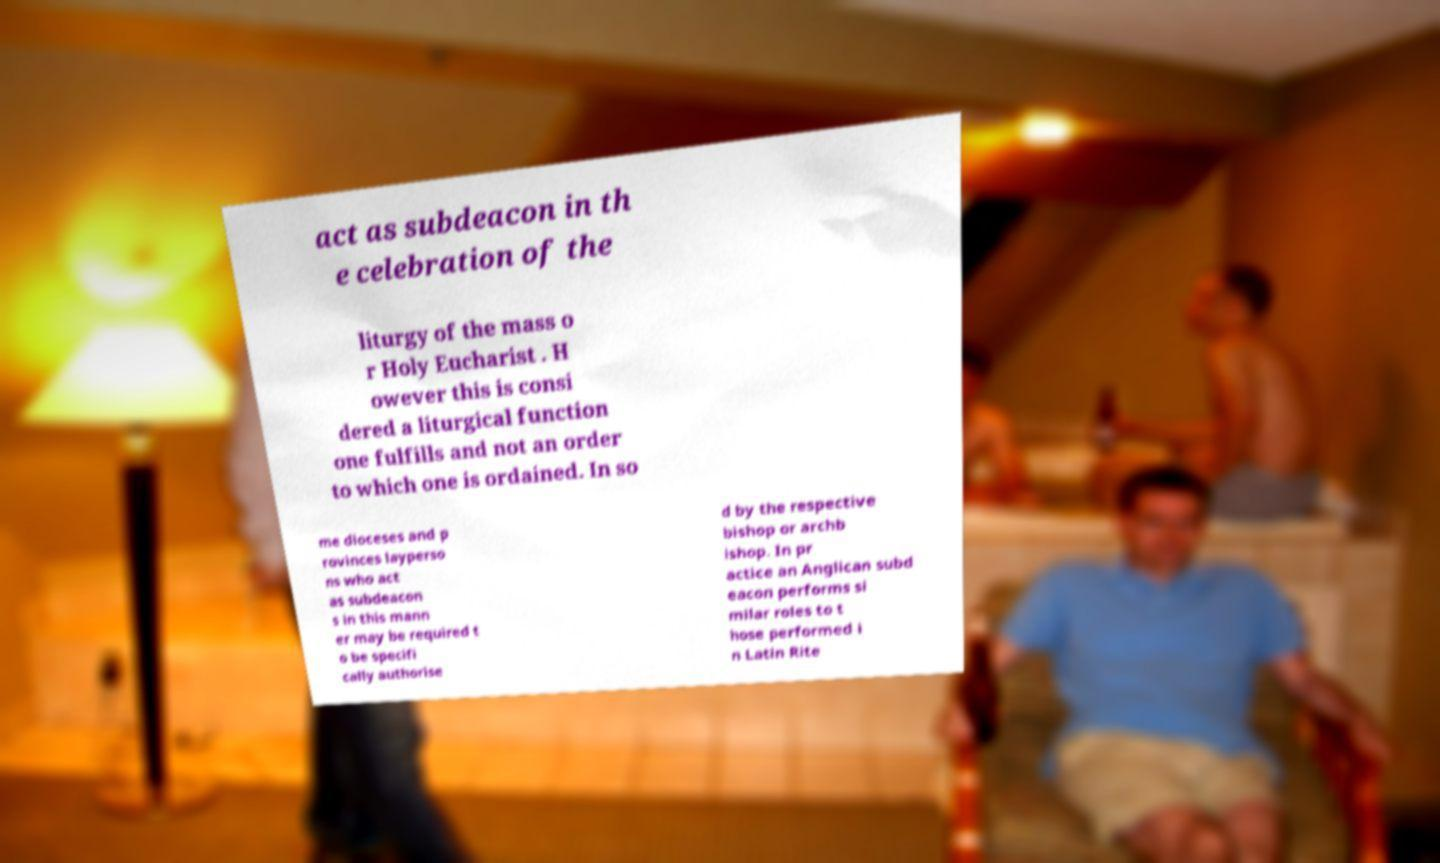For documentation purposes, I need the text within this image transcribed. Could you provide that? act as subdeacon in th e celebration of the liturgy of the mass o r Holy Eucharist . H owever this is consi dered a liturgical function one fulfills and not an order to which one is ordained. In so me dioceses and p rovinces layperso ns who act as subdeacon s in this mann er may be required t o be specifi cally authorise d by the respective bishop or archb ishop. In pr actice an Anglican subd eacon performs si milar roles to t hose performed i n Latin Rite 